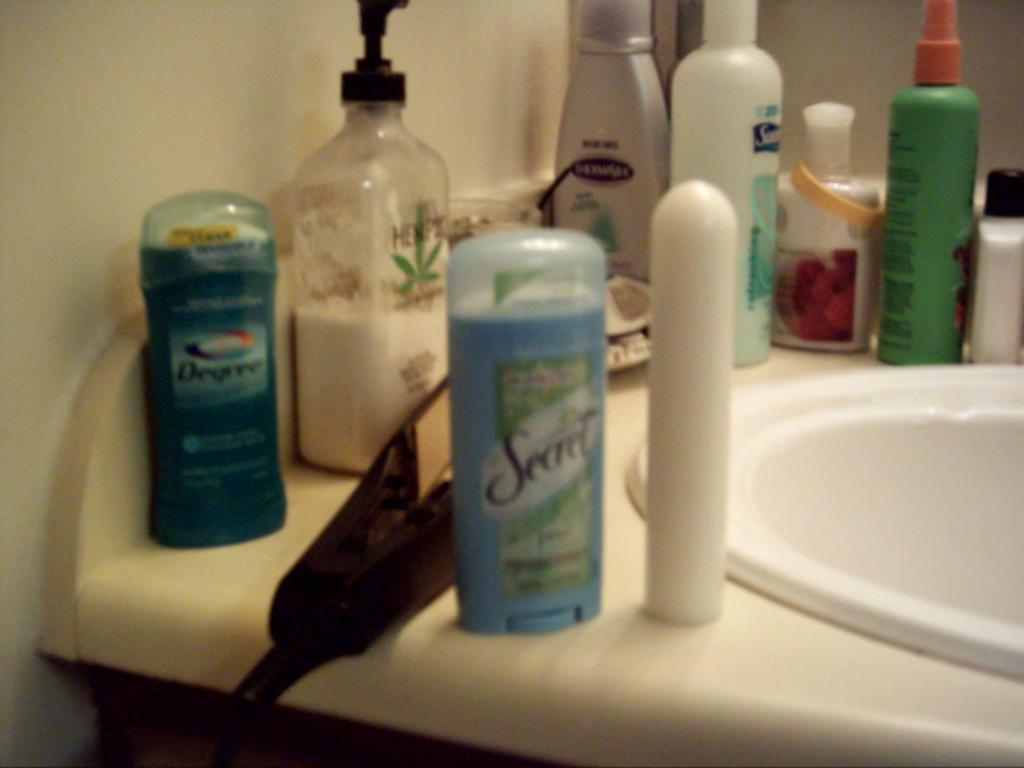Provide a one-sentence caption for the provided image. A bathroom sink with several personal product including Secret and Degree deoderant. 